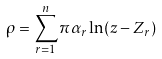Convert formula to latex. <formula><loc_0><loc_0><loc_500><loc_500>\rho = \sum _ { r = 1 } ^ { n } \pi \alpha _ { r } \ln ( z - Z _ { r } )</formula> 